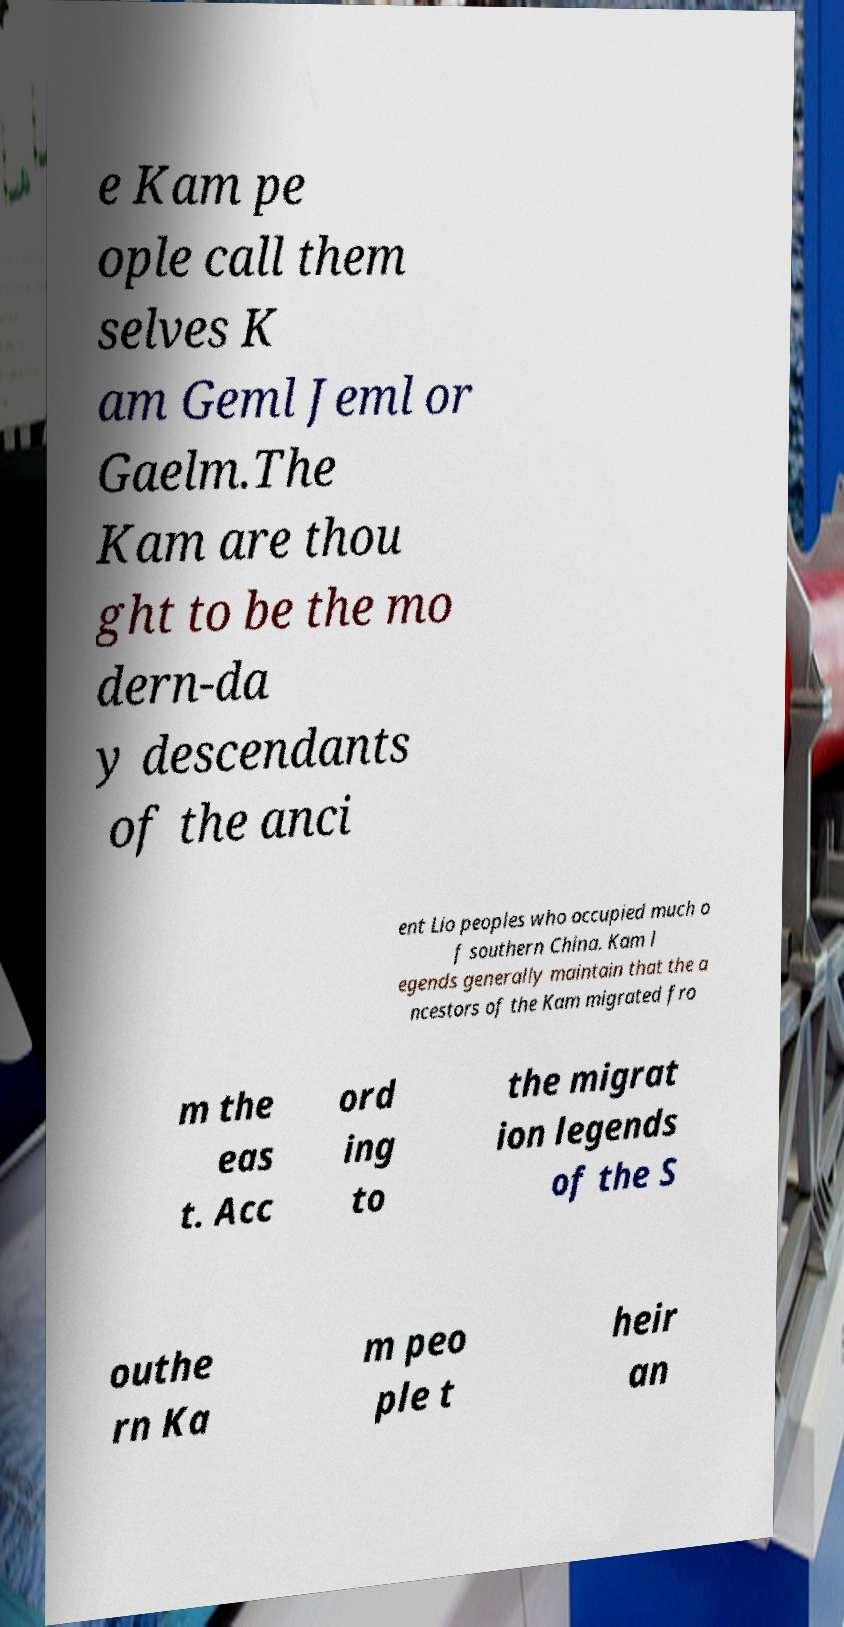I need the written content from this picture converted into text. Can you do that? e Kam pe ople call them selves K am Geml Jeml or Gaelm.The Kam are thou ght to be the mo dern-da y descendants of the anci ent Lio peoples who occupied much o f southern China. Kam l egends generally maintain that the a ncestors of the Kam migrated fro m the eas t. Acc ord ing to the migrat ion legends of the S outhe rn Ka m peo ple t heir an 